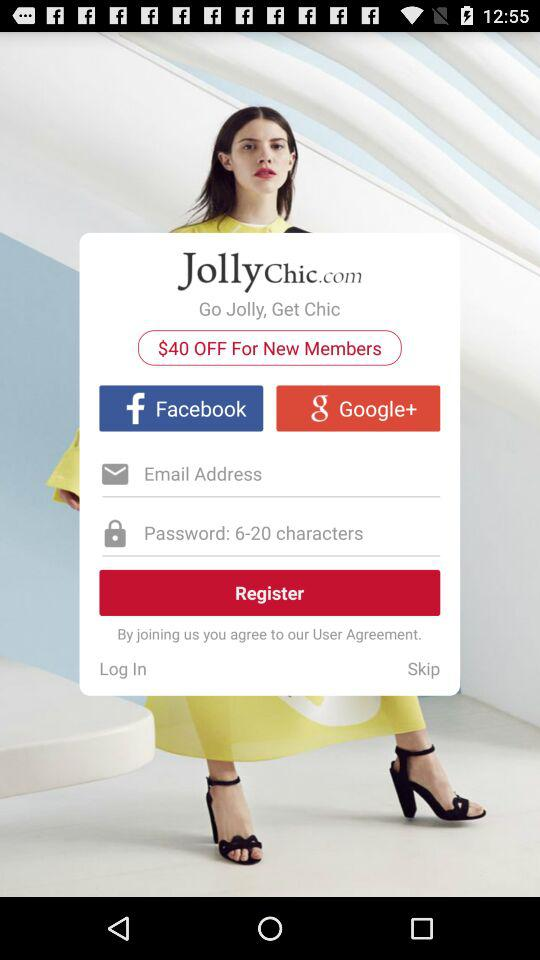What is the number of characters required for a password? The number of characters required for a password is 6 to 20. 